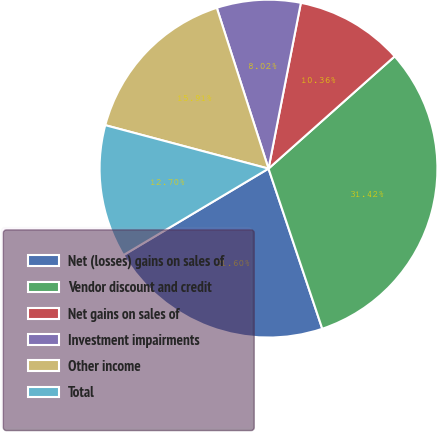<chart> <loc_0><loc_0><loc_500><loc_500><pie_chart><fcel>Net (losses) gains on sales of<fcel>Vendor discount and credit<fcel>Net gains on sales of<fcel>Investment impairments<fcel>Other income<fcel>Total<nl><fcel>21.6%<fcel>31.42%<fcel>10.36%<fcel>8.02%<fcel>15.91%<fcel>12.7%<nl></chart> 